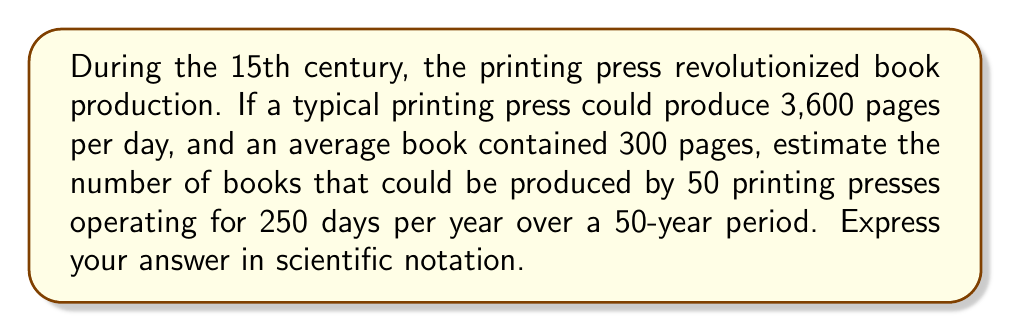Provide a solution to this math problem. Let's break this problem down step-by-step:

1. Calculate the number of pages produced by one press in a day:
   $3,600$ pages per day

2. Calculate the number of books produced by one press in a day:
   $\frac{3,600 \text{ pages}}{300 \text{ pages per book}} = 12$ books per day

3. Calculate the number of books produced by 50 presses in a day:
   $12 \text{ books} \times 50 \text{ presses} = 600$ books per day

4. Calculate the number of books produced in a year (250 working days):
   $600 \text{ books} \times 250 \text{ days} = 150,000$ books per year

5. Calculate the number of books produced over 50 years:
   $150,000 \text{ books} \times 50 \text{ years} = 7,500,000$ books

6. Express the result in scientific notation:
   $7,500,000 = 7.5 \times 10^6$

Therefore, the estimated number of books produced by 50 printing presses over a 50-year period in the 15th century is $7.5 \times 10^6$ books.
Answer: $7.5 \times 10^6$ books 